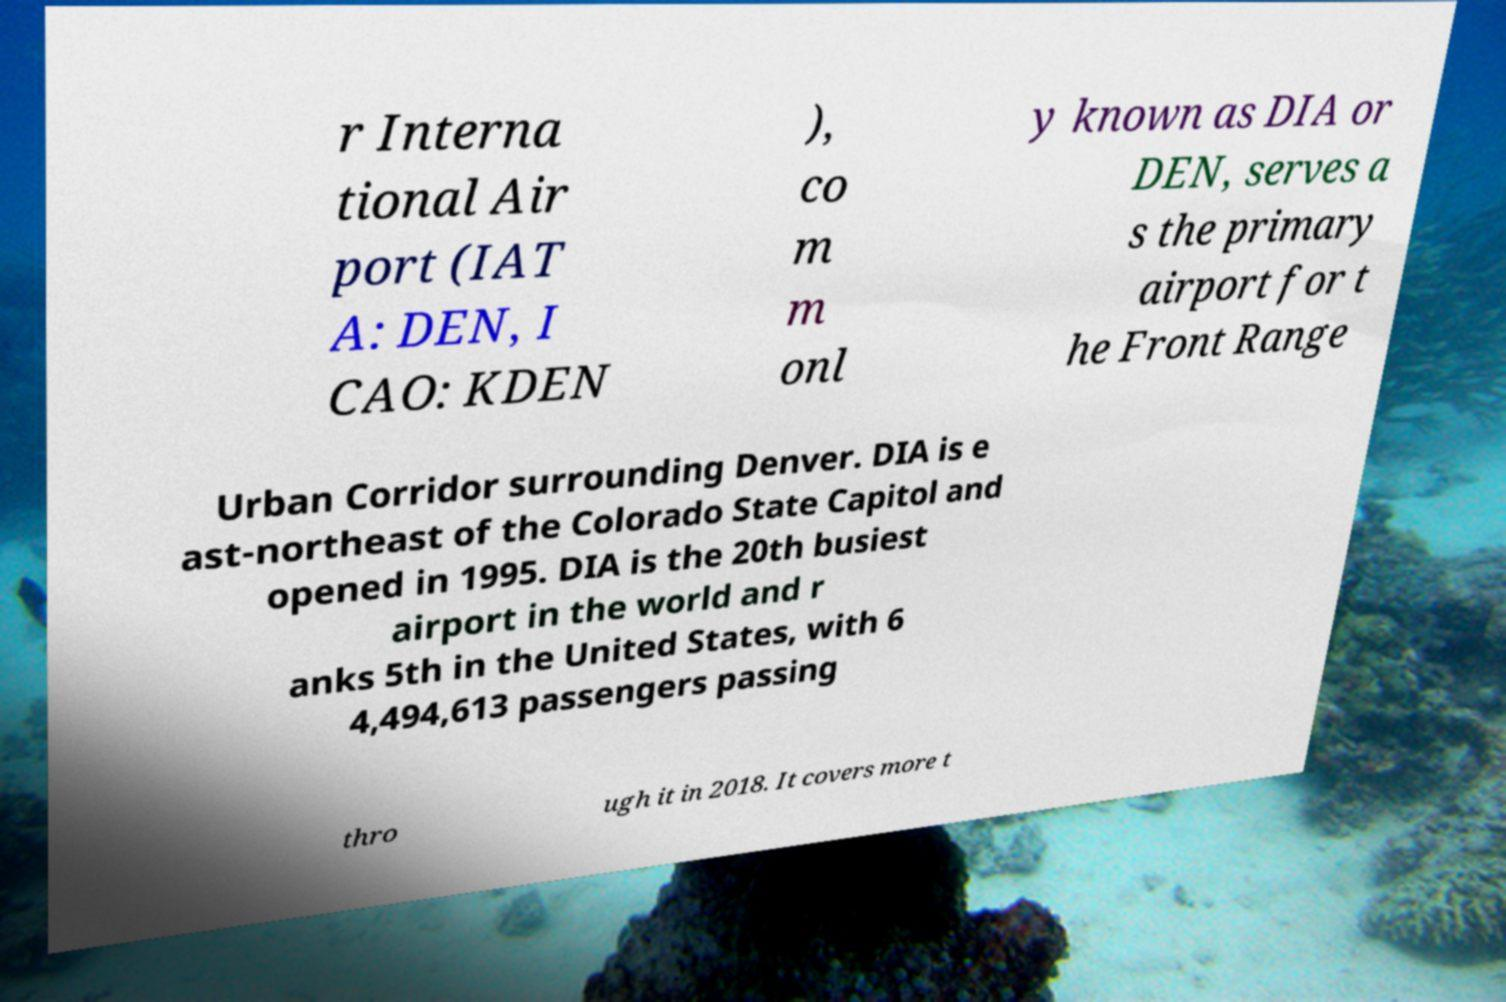For documentation purposes, I need the text within this image transcribed. Could you provide that? r Interna tional Air port (IAT A: DEN, I CAO: KDEN ), co m m onl y known as DIA or DEN, serves a s the primary airport for t he Front Range Urban Corridor surrounding Denver. DIA is e ast-northeast of the Colorado State Capitol and opened in 1995. DIA is the 20th busiest airport in the world and r anks 5th in the United States, with 6 4,494,613 passengers passing thro ugh it in 2018. It covers more t 